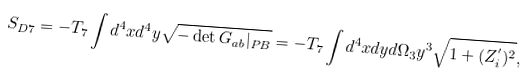Convert formula to latex. <formula><loc_0><loc_0><loc_500><loc_500>S _ { D 7 } = - T _ { 7 } \int d ^ { 4 } x d ^ { 4 } y \sqrt { - \det G _ { a b } | _ { P B } } = - T _ { 7 } \int d ^ { 4 } x d y d \Omega _ { 3 } y ^ { 3 } \sqrt { 1 + ( Z _ { i } ^ { ^ { \prime } } ) ^ { 2 } } ,</formula> 